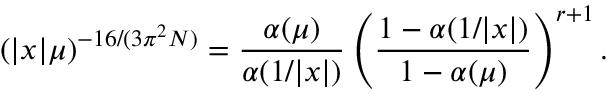Convert formula to latex. <formula><loc_0><loc_0><loc_500><loc_500>\left ( | x | \mu \right ) ^ { - 1 6 / ( 3 \pi ^ { 2 } N ) } = { \frac { \alpha ( \mu ) } { \alpha ( 1 / | x | ) } } \left ( { \frac { 1 - \alpha ( 1 / | x | ) } { 1 - \alpha ( \mu ) } } \right ) ^ { r + 1 } .</formula> 